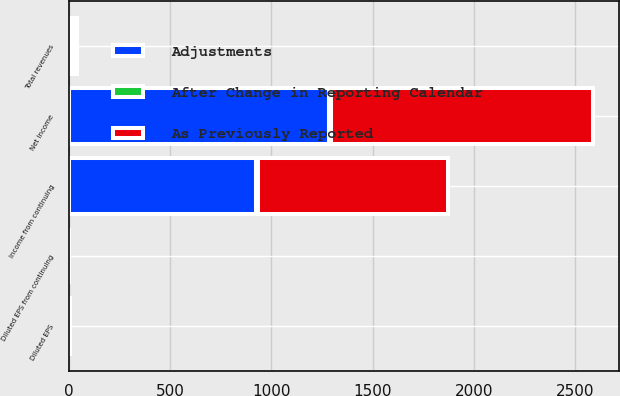Convert chart. <chart><loc_0><loc_0><loc_500><loc_500><stacked_bar_chart><ecel><fcel>Total revenues<fcel>Income from continuing<fcel>Net Income<fcel>Diluted EPS from continuing<fcel>Diluted EPS<nl><fcel>As Previously Reported<fcel>10<fcel>936<fcel>1293<fcel>2.11<fcel>2.92<nl><fcel>After Change in Reporting Calendar<fcel>22<fcel>10<fcel>10<fcel>0.02<fcel>0.02<nl><fcel>Adjustments<fcel>10<fcel>926<fcel>1283<fcel>2.09<fcel>2.9<nl></chart> 